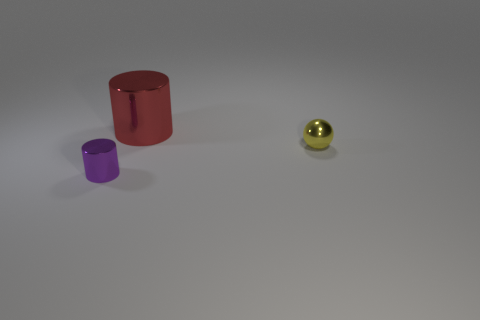Subtract 1 cylinders. How many cylinders are left? 1 Subtract all red cylinders. How many cylinders are left? 1 Add 3 large yellow metal blocks. How many objects exist? 6 Subtract all cylinders. How many objects are left? 1 Subtract all gray blocks. How many red cylinders are left? 1 Add 1 green rubber cylinders. How many green rubber cylinders exist? 1 Subtract 0 brown cylinders. How many objects are left? 3 Subtract all blue spheres. Subtract all blue cylinders. How many spheres are left? 1 Subtract all tiny brown metallic balls. Subtract all cylinders. How many objects are left? 1 Add 1 purple metallic cylinders. How many purple metallic cylinders are left? 2 